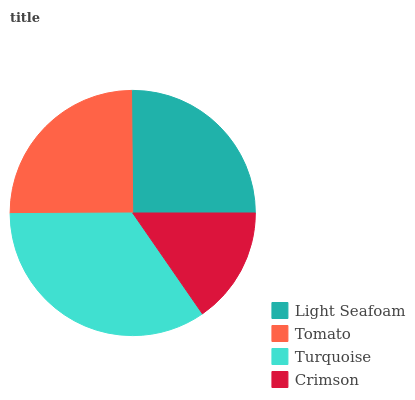Is Crimson the minimum?
Answer yes or no. Yes. Is Turquoise the maximum?
Answer yes or no. Yes. Is Tomato the minimum?
Answer yes or no. No. Is Tomato the maximum?
Answer yes or no. No. Is Light Seafoam greater than Tomato?
Answer yes or no. Yes. Is Tomato less than Light Seafoam?
Answer yes or no. Yes. Is Tomato greater than Light Seafoam?
Answer yes or no. No. Is Light Seafoam less than Tomato?
Answer yes or no. No. Is Light Seafoam the high median?
Answer yes or no. Yes. Is Tomato the low median?
Answer yes or no. Yes. Is Turquoise the high median?
Answer yes or no. No. Is Light Seafoam the low median?
Answer yes or no. No. 